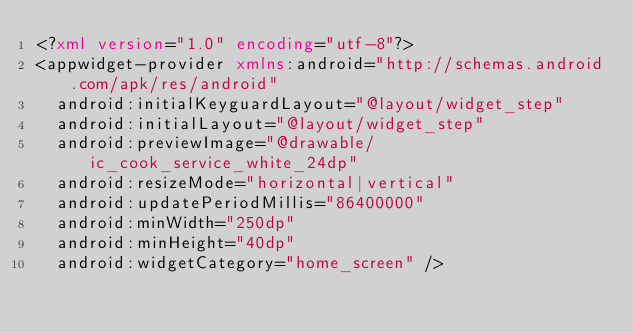<code> <loc_0><loc_0><loc_500><loc_500><_XML_><?xml version="1.0" encoding="utf-8"?>
<appwidget-provider xmlns:android="http://schemas.android.com/apk/res/android"
	android:initialKeyguardLayout="@layout/widget_step"
	android:initialLayout="@layout/widget_step"
	android:previewImage="@drawable/ic_cook_service_white_24dp"
	android:resizeMode="horizontal|vertical"
	android:updatePeriodMillis="86400000"
	android:minWidth="250dp"
	android:minHeight="40dp"
	android:widgetCategory="home_screen" /></code> 